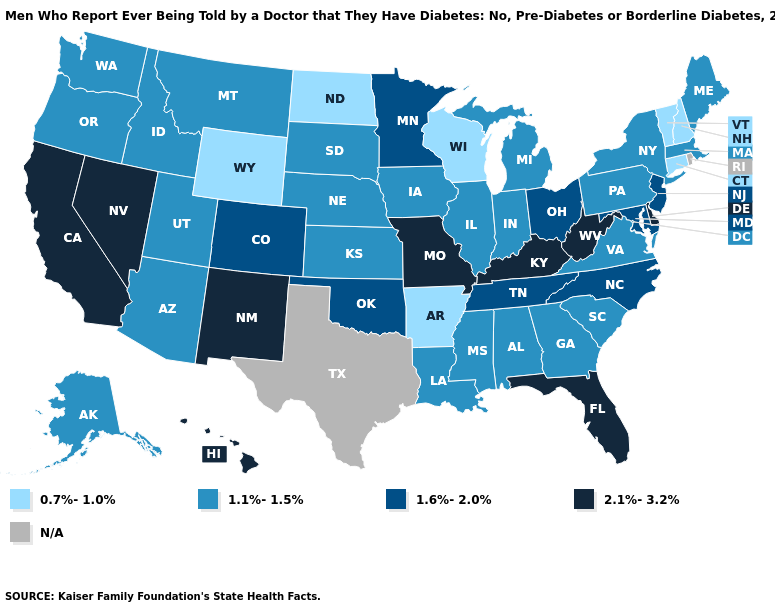What is the value of North Carolina?
Give a very brief answer. 1.6%-2.0%. Which states have the highest value in the USA?
Be succinct. California, Delaware, Florida, Hawaii, Kentucky, Missouri, Nevada, New Mexico, West Virginia. Name the states that have a value in the range 1.6%-2.0%?
Give a very brief answer. Colorado, Maryland, Minnesota, New Jersey, North Carolina, Ohio, Oklahoma, Tennessee. Name the states that have a value in the range 2.1%-3.2%?
Concise answer only. California, Delaware, Florida, Hawaii, Kentucky, Missouri, Nevada, New Mexico, West Virginia. Which states have the highest value in the USA?
Short answer required. California, Delaware, Florida, Hawaii, Kentucky, Missouri, Nevada, New Mexico, West Virginia. What is the value of Tennessee?
Short answer required. 1.6%-2.0%. Does the first symbol in the legend represent the smallest category?
Short answer required. Yes. What is the highest value in states that border Idaho?
Concise answer only. 2.1%-3.2%. What is the value of Delaware?
Be succinct. 2.1%-3.2%. What is the highest value in the USA?
Concise answer only. 2.1%-3.2%. What is the value of North Dakota?
Quick response, please. 0.7%-1.0%. What is the lowest value in states that border Vermont?
Keep it brief. 0.7%-1.0%. What is the value of Pennsylvania?
Give a very brief answer. 1.1%-1.5%. What is the value of New Hampshire?
Answer briefly. 0.7%-1.0%. 